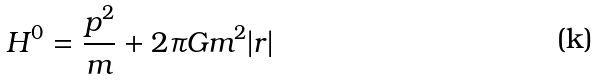<formula> <loc_0><loc_0><loc_500><loc_500>H ^ { 0 } = \frac { p ^ { 2 } } { m } + 2 \pi G m ^ { 2 } | r |</formula> 